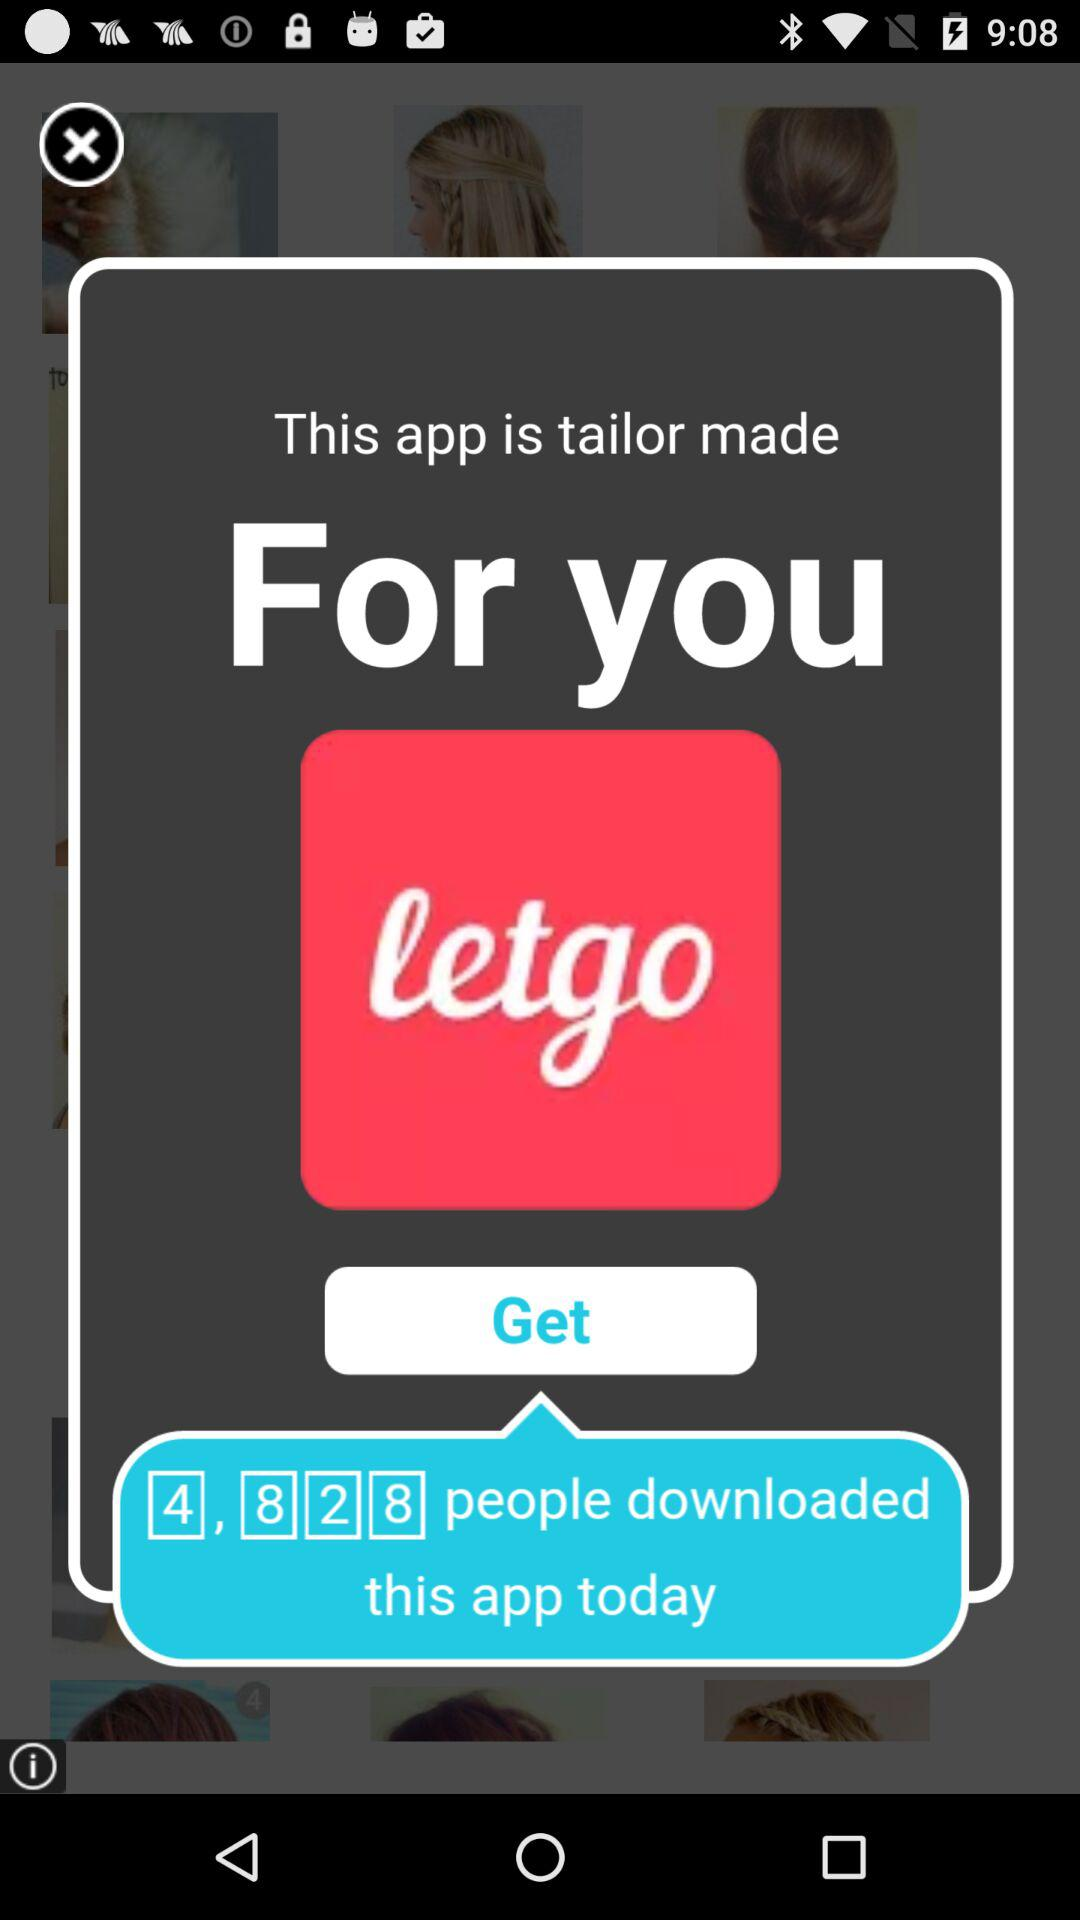What is the application name? The application name is "letgo". 